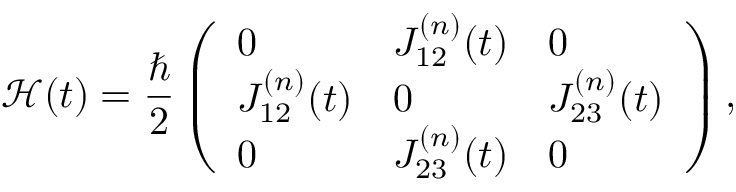Convert formula to latex. <formula><loc_0><loc_0><loc_500><loc_500>\mathcal { H } ( t ) = \frac { } { 2 } \left ( \begin{array} { l l l } { 0 } & { J _ { 1 2 } ^ { ( n ) } ( t ) } & { 0 } \\ { J _ { 1 2 } ^ { ( n ) } ( t ) } & { 0 } & { J _ { 2 3 } ^ { ( n ) } ( t ) } \\ { 0 } & { J _ { 2 3 } ^ { ( n ) } ( t ) } & { 0 } \end{array} \right ) ,</formula> 